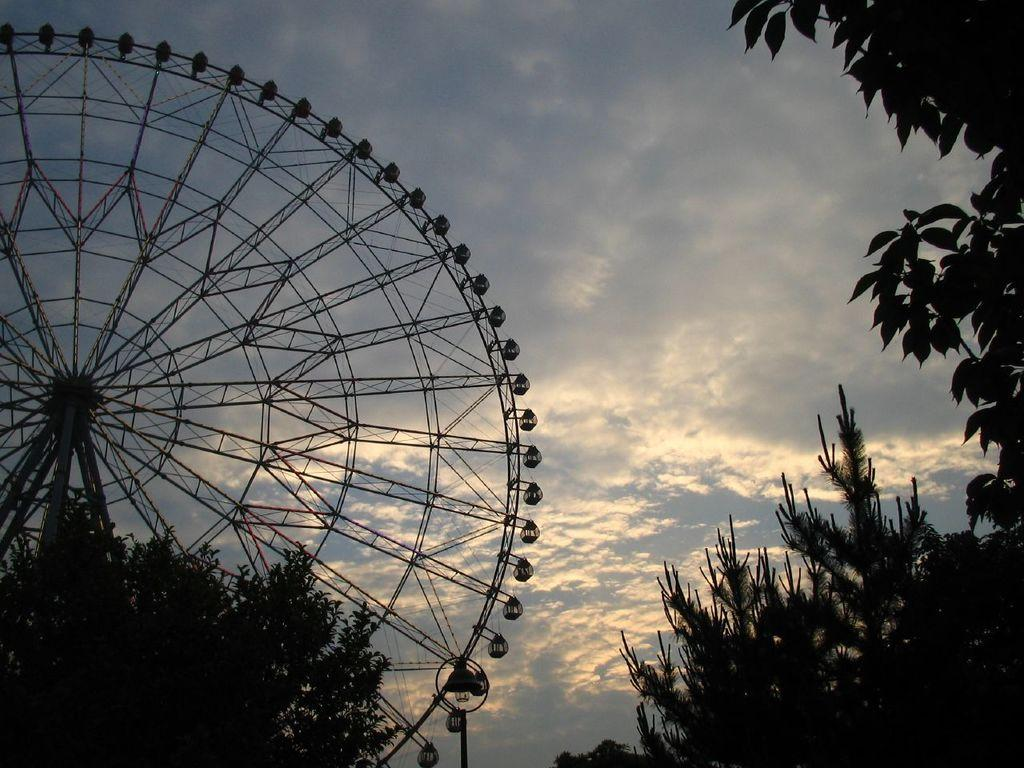What is the main structure in the image? There is a giant wheel in the image. What type of natural elements can be seen in the image? There are trees in the image. What is visible in the background of the image? The sky is visible in the image. What can be observed in the sky? Clouds are present in the sky. What type of can is being used by the monkey in the image? There is no monkey or can present in the image. 